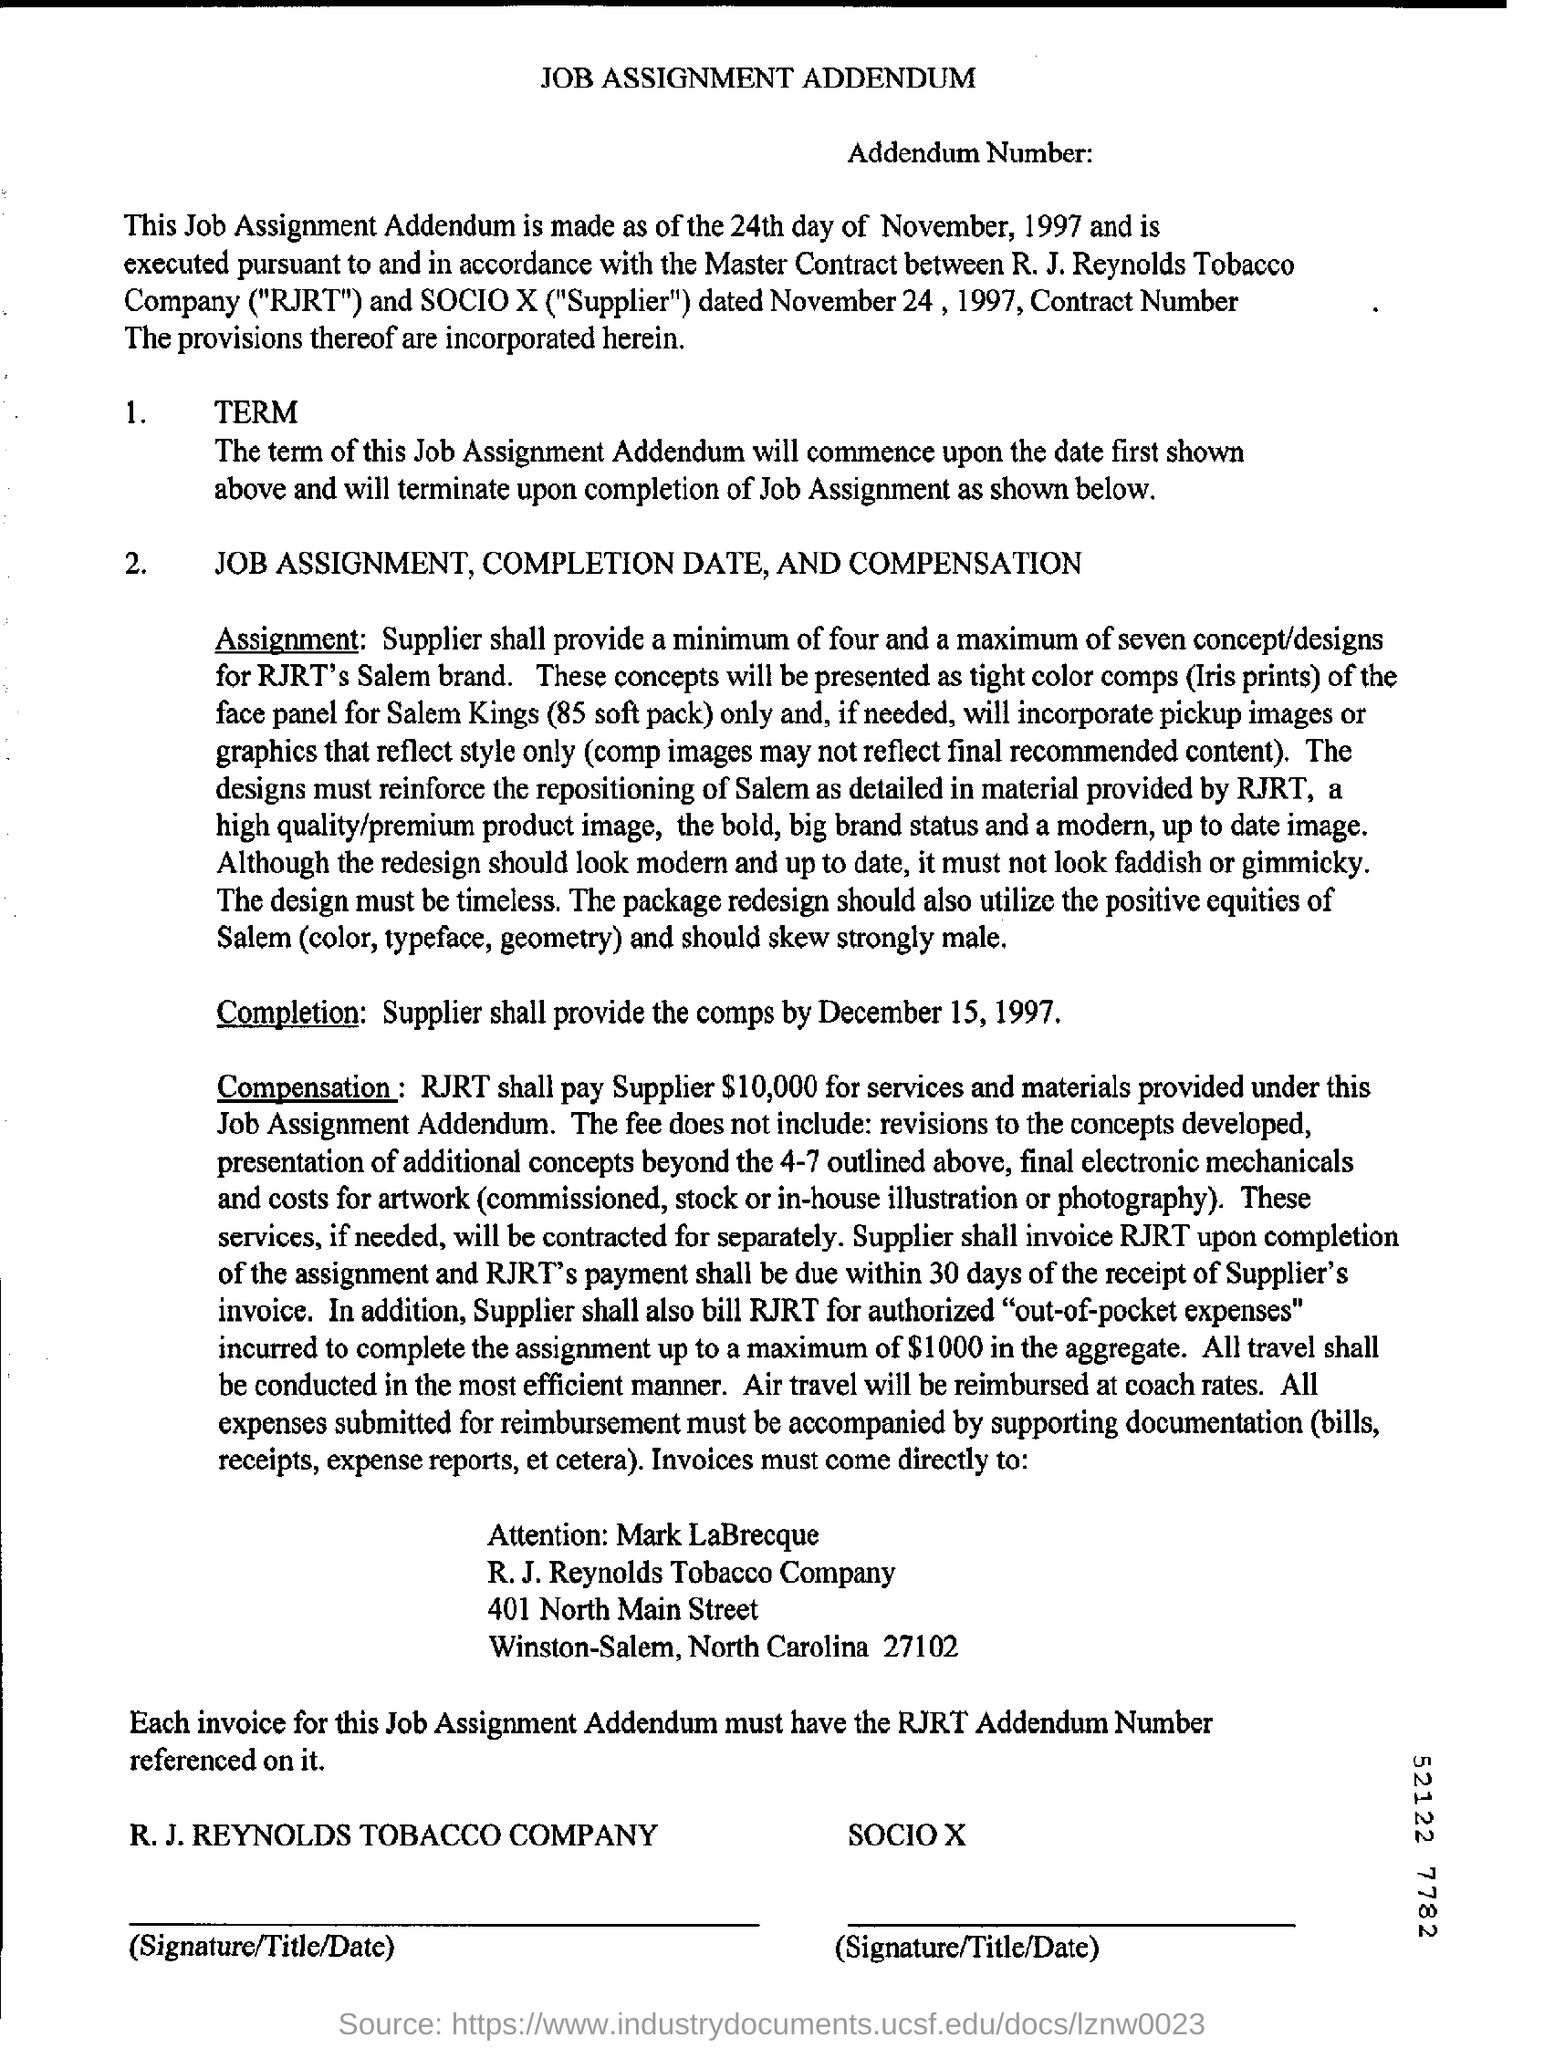Identify some key points in this picture. R.J. Reynolds Tobacco Company is an entity known as RJRT. The heading at the top of the page is 'Job Assignment Addendum.' 